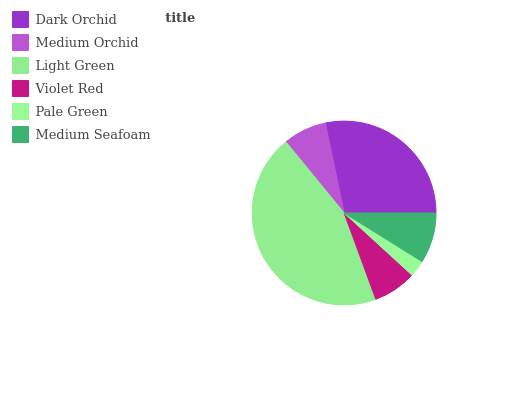Is Pale Green the minimum?
Answer yes or no. Yes. Is Light Green the maximum?
Answer yes or no. Yes. Is Medium Orchid the minimum?
Answer yes or no. No. Is Medium Orchid the maximum?
Answer yes or no. No. Is Dark Orchid greater than Medium Orchid?
Answer yes or no. Yes. Is Medium Orchid less than Dark Orchid?
Answer yes or no. Yes. Is Medium Orchid greater than Dark Orchid?
Answer yes or no. No. Is Dark Orchid less than Medium Orchid?
Answer yes or no. No. Is Medium Seafoam the high median?
Answer yes or no. Yes. Is Medium Orchid the low median?
Answer yes or no. Yes. Is Dark Orchid the high median?
Answer yes or no. No. Is Light Green the low median?
Answer yes or no. No. 